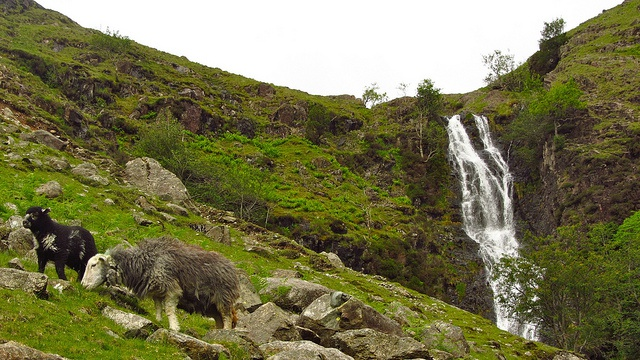Describe the objects in this image and their specific colors. I can see sheep in black, olive, and gray tones and sheep in black, gray, and darkgreen tones in this image. 